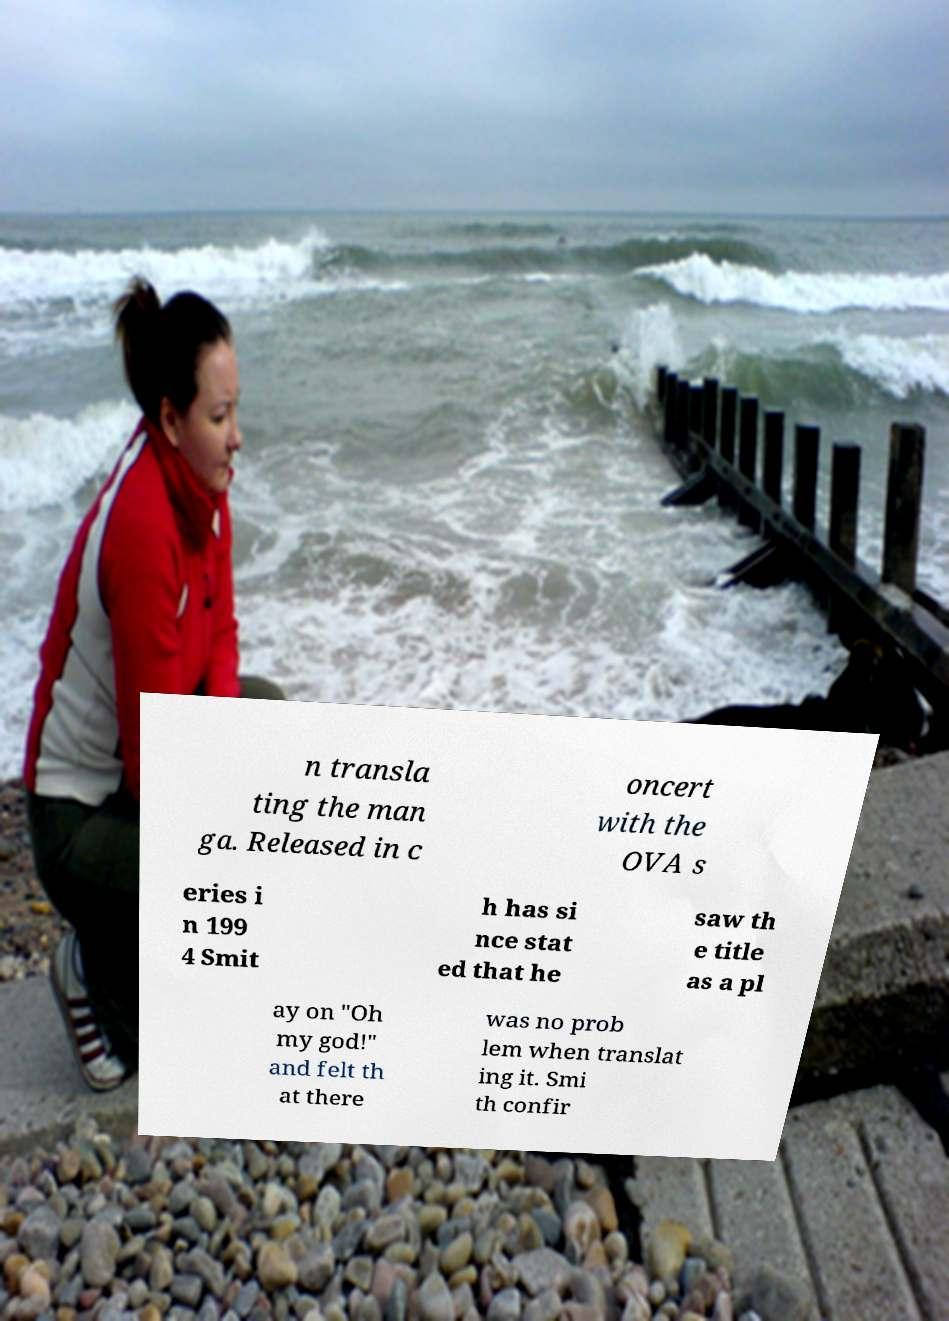Could you extract and type out the text from this image? n transla ting the man ga. Released in c oncert with the OVA s eries i n 199 4 Smit h has si nce stat ed that he saw th e title as a pl ay on "Oh my god!" and felt th at there was no prob lem when translat ing it. Smi th confir 